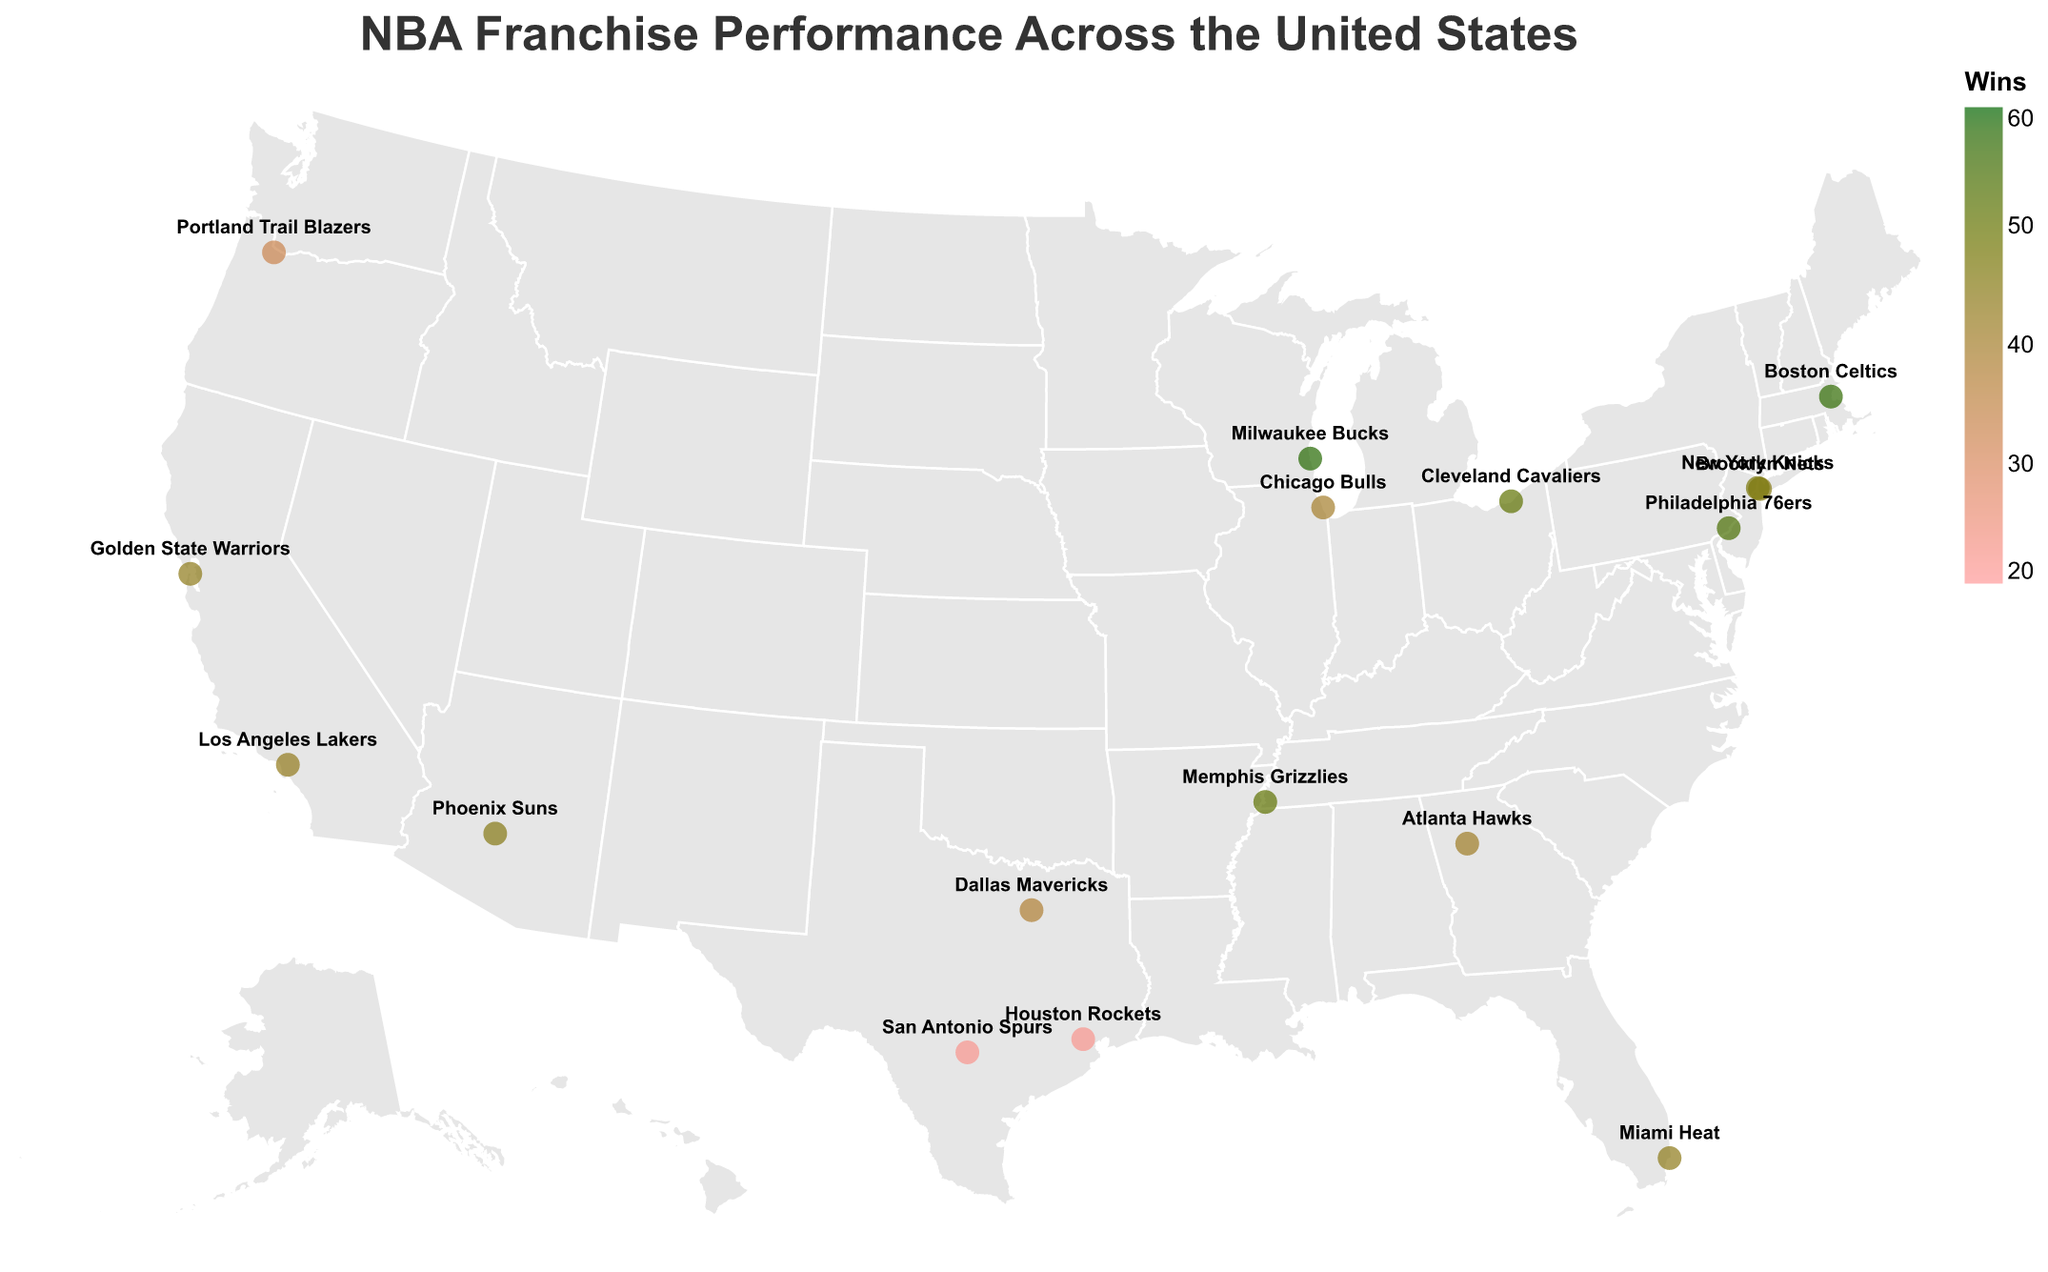Which NBA team is located in Miami? The tooltip in the plot would indicate the team name when hovering over Miami. According to the data, the team located in Miami is the Miami Heat.
Answer: Miami Heat Which NBA team had the highest number of wins? The color of the circle representing each team indicates the number of wins. Darker green colors signify higher wins. By noting the team with the darkest green circle, we find the Milwaukee Bucks had the most wins at 58.
Answer: Milwaukee Bucks What is the geographical distribution of the NBA teams with the least number of wins? Teams with fewer wins are represented by lighter red circles. According to the data, the Houston Rockets and San Antonio Spurs, both in Texas, have the least wins at 22 each.
Answer: Houston Rockets and San Antonio Spurs Which NBA team in California has a better win-loss record? California has two teams represented: Golden State Warriors and Los Angeles Lakers. By comparing their respective data (Golden State: 44-38, Los Angeles: 43-39), the Golden State Warriors have a slightly better win-loss record.
Answer: Golden State Warriors How do the win-loss records of the Atlanta Hawks and the Brooklyn Nets compare? Looking at the data, Atlanta Hawks have a record of 41-41 while Brooklyn Nets have a record of 45-37. Brooklyn Nets have more wins and fewer losses compared to Atlanta Hawks.
Answer: Brooklyn Nets What's the overall win percentage for the Phoenix Suns? The win percentage can be calculated using the formula Wins / (Wins + Losses). For Phoenix Suns: 45 / (45 + 37) = 45 / 82 ≈ 0.5488 or approximately 54.88%.
Answer: 54.88% Which city has two NBA teams according to the plot? By observing the labels on the plot, New York has two NBA teams: Brooklyn Nets and New York Knicks.
Answer: New York What's the average number of wins for the teams located in Texas? The teams in Texas include Dallas Mavericks, Houston Rockets, and San Antonio Spurs. Their win counts are 38, 22, and 22 respectively. The average is calculated as (38 + 22 + 22) / 3 = 27.33.
Answer: 27.33 Which team has a win-loss record closest to 50-50? A 50-50 record implies an equal number of wins and losses. The closest team to this balance is the Atlanta Hawks with a record of 41-41.
Answer: Atlanta Hawks How many teams have more than 50 wins in the season? Based on the color gradient and data, teams with more than 50 wins are: Boston Celtics (57), Cleveland Cavaliers (51), Memphis Grizzlies (51), Milwaukee Bucks (58), and Philadelphia 76ers (54). This totals to five teams.
Answer: 5 